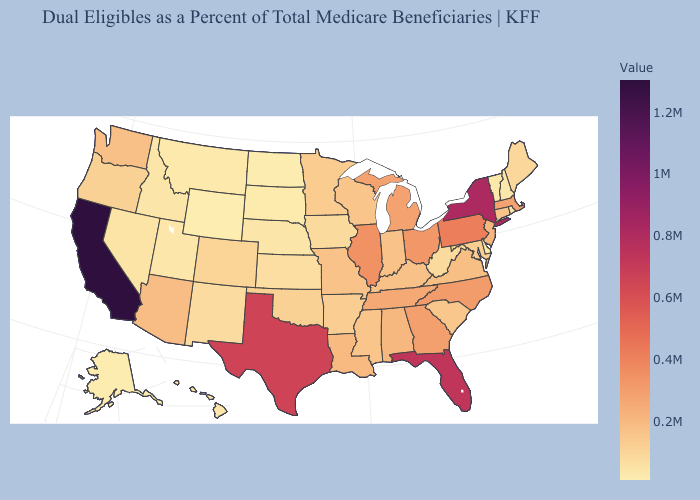Does Wyoming have the lowest value in the USA?
Be succinct. Yes. Does Wyoming have the lowest value in the West?
Answer briefly. Yes. Does New York have the lowest value in the USA?
Short answer required. No. Does the map have missing data?
Be succinct. No. Which states have the highest value in the USA?
Keep it brief. California. 